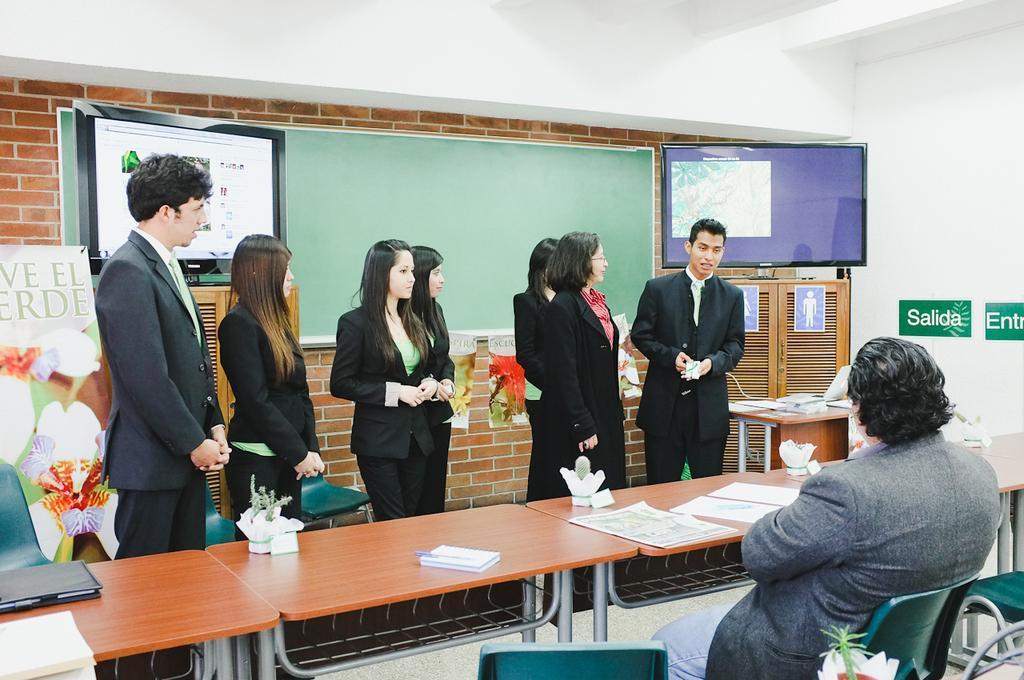Describe this image in one or two sentences. This image is taken inside a room. There were few people in this room and there is a table, chairs, a board, monitor, poster with text, wall and a cupboard in this room. 